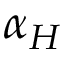<formula> <loc_0><loc_0><loc_500><loc_500>\alpha _ { H }</formula> 